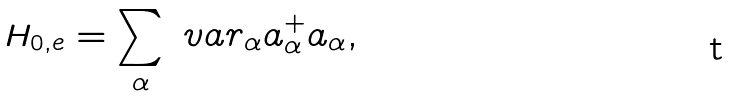Convert formula to latex. <formula><loc_0><loc_0><loc_500><loc_500>H _ { 0 , e } = \sum _ { \alpha } \ v a r _ { \alpha } a ^ { + } _ { \alpha } a _ { \alpha } ,</formula> 